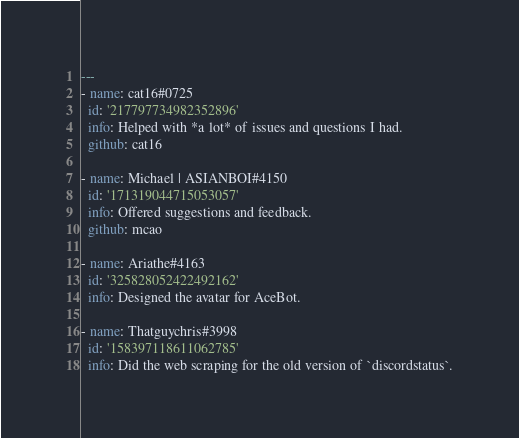Convert code to text. <code><loc_0><loc_0><loc_500><loc_500><_YAML_>---
- name: cat16#0725
  id: '217797734982352896'
  info: Helped with *a lot* of issues and questions I had.
  github: cat16

- name: Michael | ASIANBOI#4150
  id: '171319044715053057'
  info: Offered suggestions and feedback.
  github: mcao

- name: Ariathe#4163
  id: '325828052422492162'
  info: Designed the avatar for AceBot.

- name: Thatguychris#3998
  id: '158397118611062785'
  info: Did the web scraping for the old version of `discordstatus`.
</code> 